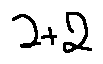<formula> <loc_0><loc_0><loc_500><loc_500>2 + 2</formula> 